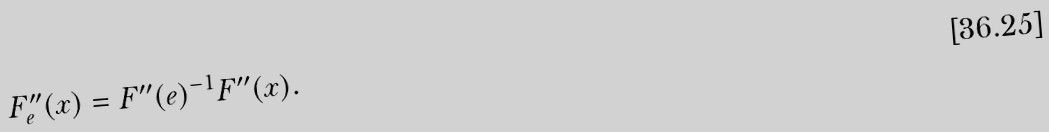<formula> <loc_0><loc_0><loc_500><loc_500>F _ { e } ^ { \prime \prime } ( x ) = F ^ { \prime \prime } ( e ) ^ { - 1 } F ^ { \prime \prime } ( x ) .</formula> 